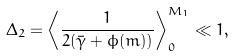<formula> <loc_0><loc_0><loc_500><loc_500>\Delta _ { 2 } = \left \langle \frac { 1 } { 2 ( \bar { \gamma } + \phi ( m ) ) } \right \rangle ^ { M _ { 1 } } _ { 0 } \ll 1 ,</formula> 